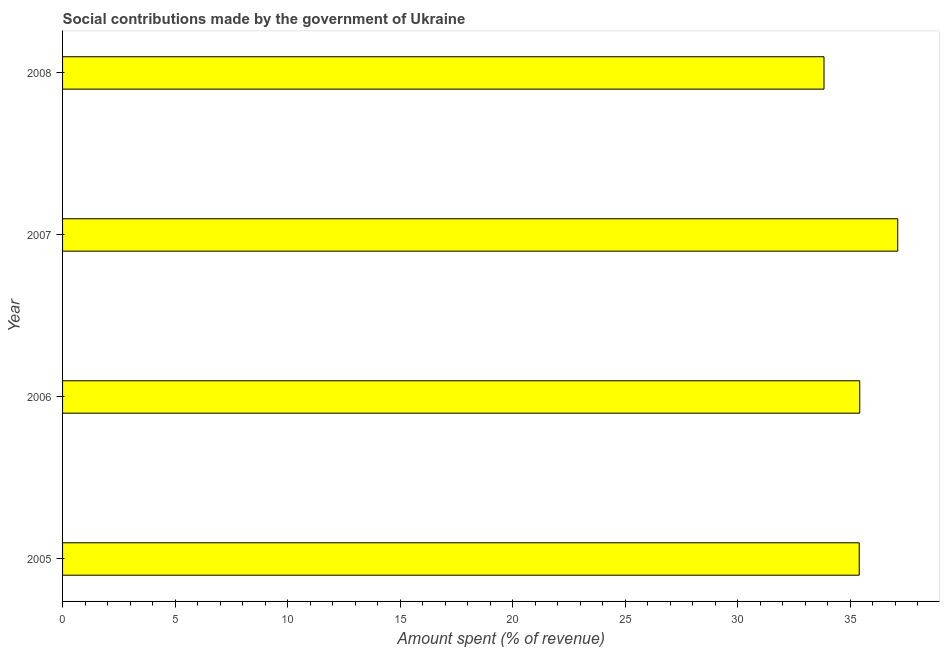Does the graph contain any zero values?
Your response must be concise. No. Does the graph contain grids?
Give a very brief answer. No. What is the title of the graph?
Your answer should be very brief. Social contributions made by the government of Ukraine. What is the label or title of the X-axis?
Provide a short and direct response. Amount spent (% of revenue). What is the amount spent in making social contributions in 2008?
Offer a very short reply. 33.84. Across all years, what is the maximum amount spent in making social contributions?
Give a very brief answer. 37.12. Across all years, what is the minimum amount spent in making social contributions?
Offer a very short reply. 33.84. What is the sum of the amount spent in making social contributions?
Make the answer very short. 141.79. What is the difference between the amount spent in making social contributions in 2006 and 2008?
Your answer should be very brief. 1.59. What is the average amount spent in making social contributions per year?
Provide a short and direct response. 35.45. What is the median amount spent in making social contributions?
Offer a terse response. 35.42. In how many years, is the amount spent in making social contributions greater than 4 %?
Provide a short and direct response. 4. What is the ratio of the amount spent in making social contributions in 2005 to that in 2008?
Your response must be concise. 1.05. What is the difference between the highest and the second highest amount spent in making social contributions?
Ensure brevity in your answer.  1.69. Is the sum of the amount spent in making social contributions in 2006 and 2008 greater than the maximum amount spent in making social contributions across all years?
Offer a terse response. Yes. What is the difference between the highest and the lowest amount spent in making social contributions?
Ensure brevity in your answer.  3.28. How many bars are there?
Your response must be concise. 4. How many years are there in the graph?
Ensure brevity in your answer.  4. What is the difference between two consecutive major ticks on the X-axis?
Your answer should be very brief. 5. Are the values on the major ticks of X-axis written in scientific E-notation?
Your answer should be compact. No. What is the Amount spent (% of revenue) in 2005?
Provide a short and direct response. 35.4. What is the Amount spent (% of revenue) of 2006?
Ensure brevity in your answer.  35.43. What is the Amount spent (% of revenue) of 2007?
Provide a succinct answer. 37.12. What is the Amount spent (% of revenue) of 2008?
Provide a short and direct response. 33.84. What is the difference between the Amount spent (% of revenue) in 2005 and 2006?
Offer a terse response. -0.02. What is the difference between the Amount spent (% of revenue) in 2005 and 2007?
Your answer should be very brief. -1.71. What is the difference between the Amount spent (% of revenue) in 2005 and 2008?
Keep it short and to the point. 1.57. What is the difference between the Amount spent (% of revenue) in 2006 and 2007?
Give a very brief answer. -1.69. What is the difference between the Amount spent (% of revenue) in 2006 and 2008?
Ensure brevity in your answer.  1.59. What is the difference between the Amount spent (% of revenue) in 2007 and 2008?
Your answer should be very brief. 3.28. What is the ratio of the Amount spent (% of revenue) in 2005 to that in 2006?
Ensure brevity in your answer.  1. What is the ratio of the Amount spent (% of revenue) in 2005 to that in 2007?
Your answer should be compact. 0.95. What is the ratio of the Amount spent (% of revenue) in 2005 to that in 2008?
Your answer should be very brief. 1.05. What is the ratio of the Amount spent (% of revenue) in 2006 to that in 2007?
Your answer should be compact. 0.95. What is the ratio of the Amount spent (% of revenue) in 2006 to that in 2008?
Ensure brevity in your answer.  1.05. What is the ratio of the Amount spent (% of revenue) in 2007 to that in 2008?
Keep it short and to the point. 1.1. 